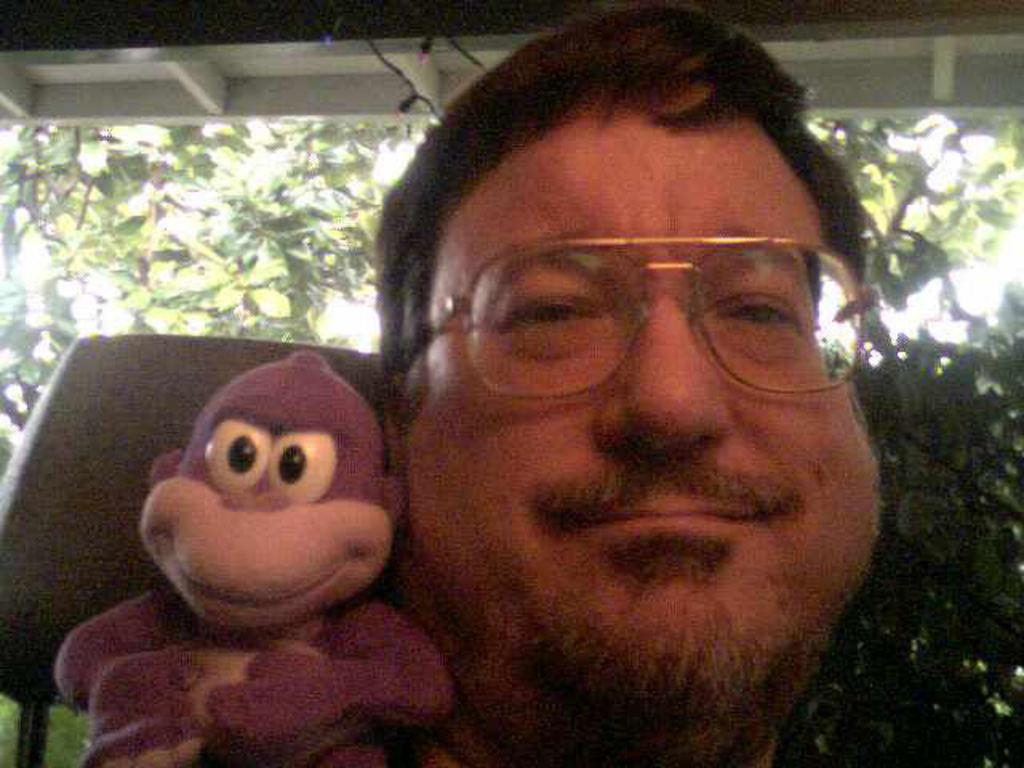Who is present in the image? There is a person in the image. What is the person doing in the image? The person is smiling and holding a toy. What can be seen in the background of the image? There is a tree, sky, and a building visible in the background of the image. What type of dinner is being served in the image? There is no dinner present in the image; it features a person holding a toy. How many beds are visible in the image? There are no beds visible in the image. 